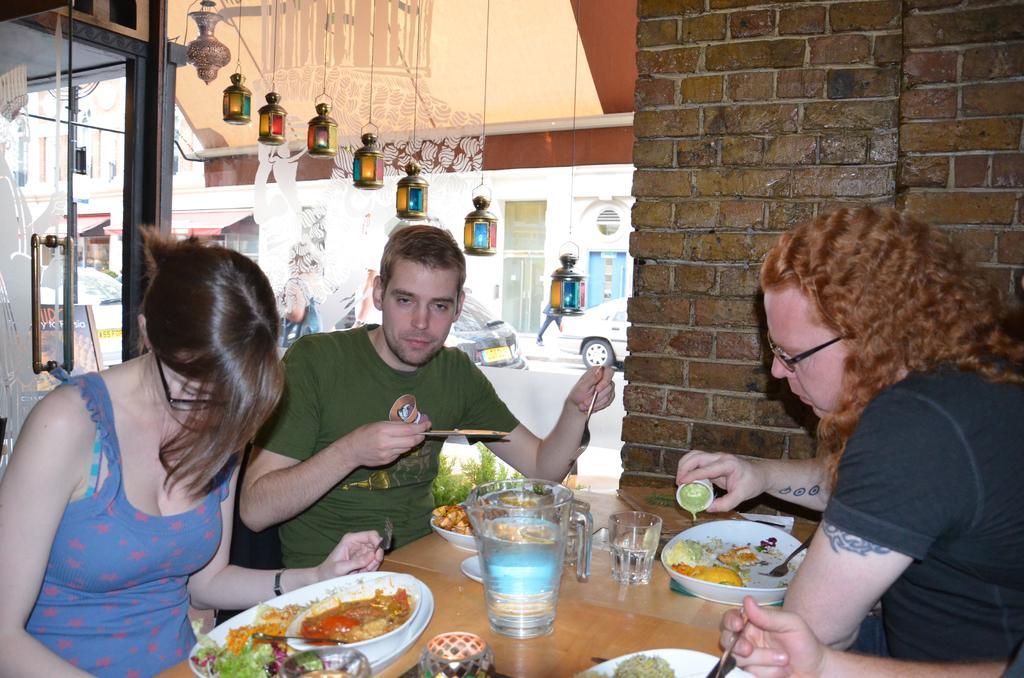Describe this image in one or two sentences. In the middle there is a table on the table there is a plate ,glass ,jug ,bowl and many food items on that. In the right there is a man he wear a black t shirt ,his hair is curly. On the left there is a woman with blue dress. In the middle there is a man he wear green t shirt. In the background there is a wall ,car ,door ,glass,lamp. 